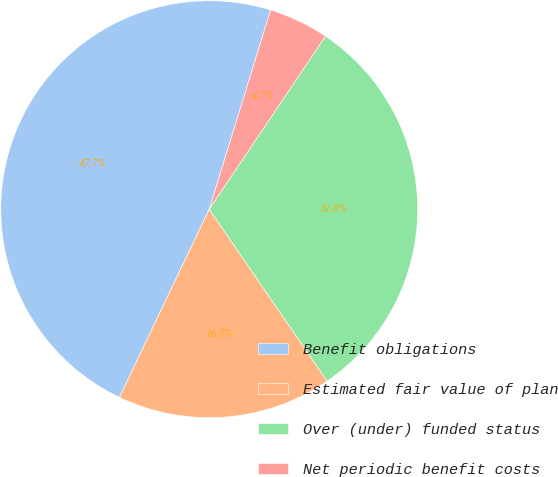Convert chart. <chart><loc_0><loc_0><loc_500><loc_500><pie_chart><fcel>Benefit obligations<fcel>Estimated fair value of plan<fcel>Over (under) funded status<fcel>Net periodic benefit costs<nl><fcel>47.67%<fcel>16.66%<fcel>31.01%<fcel>4.66%<nl></chart> 